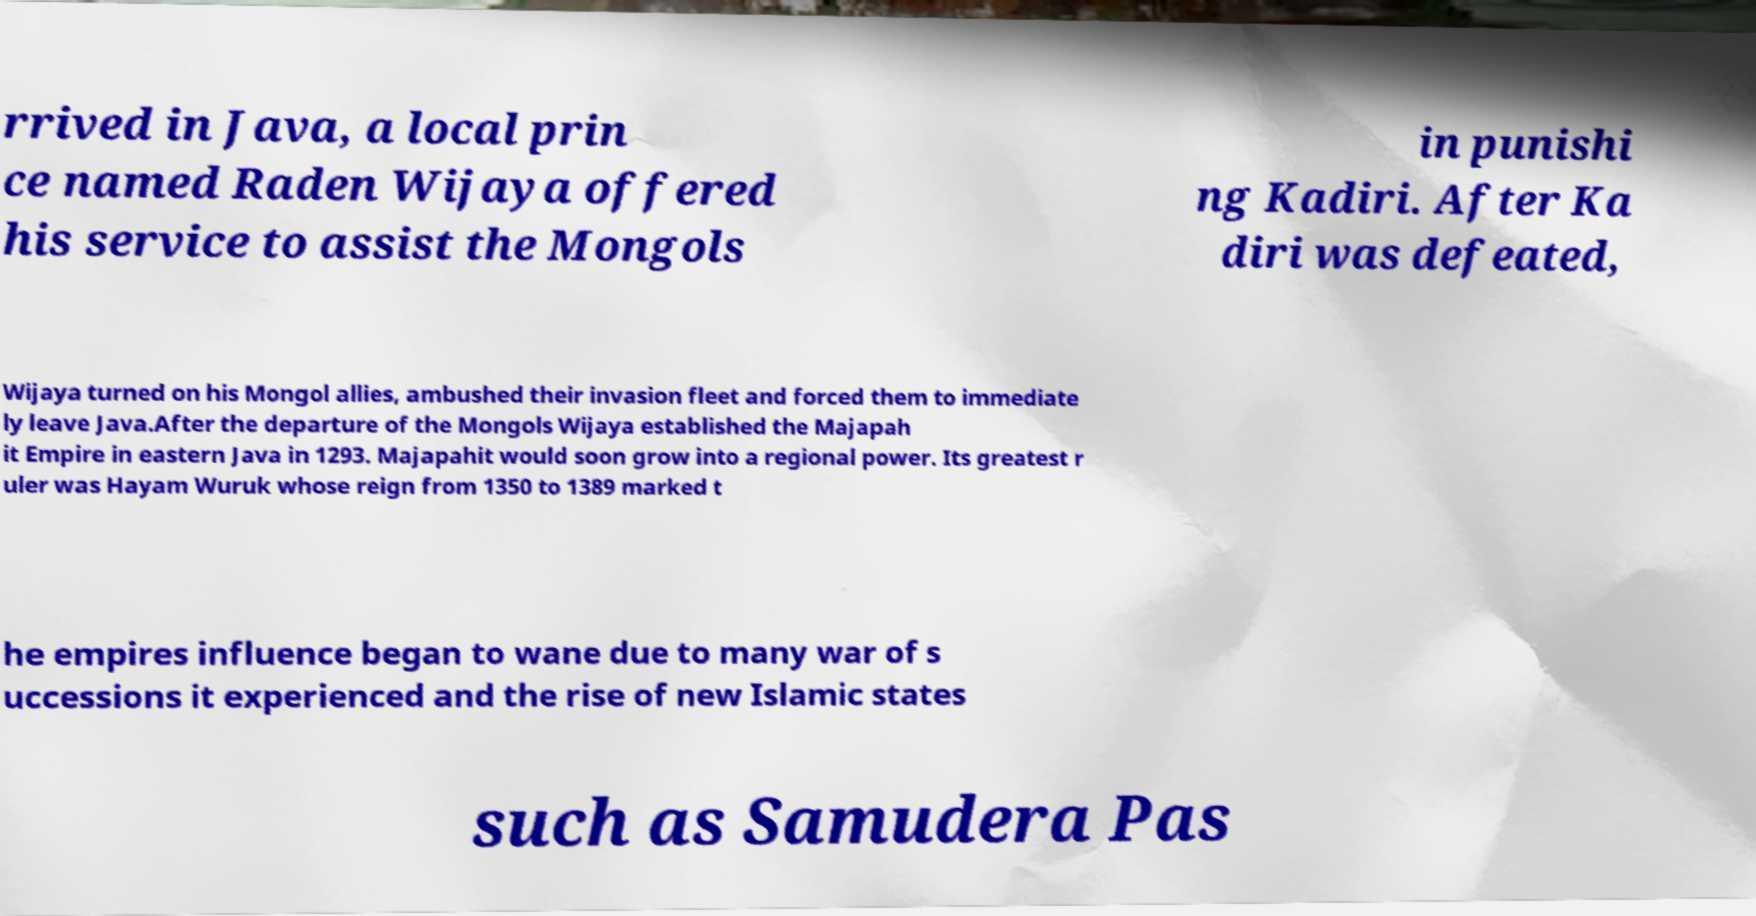For documentation purposes, I need the text within this image transcribed. Could you provide that? rrived in Java, a local prin ce named Raden Wijaya offered his service to assist the Mongols in punishi ng Kadiri. After Ka diri was defeated, Wijaya turned on his Mongol allies, ambushed their invasion fleet and forced them to immediate ly leave Java.After the departure of the Mongols Wijaya established the Majapah it Empire in eastern Java in 1293. Majapahit would soon grow into a regional power. Its greatest r uler was Hayam Wuruk whose reign from 1350 to 1389 marked t he empires influence began to wane due to many war of s uccessions it experienced and the rise of new Islamic states such as Samudera Pas 